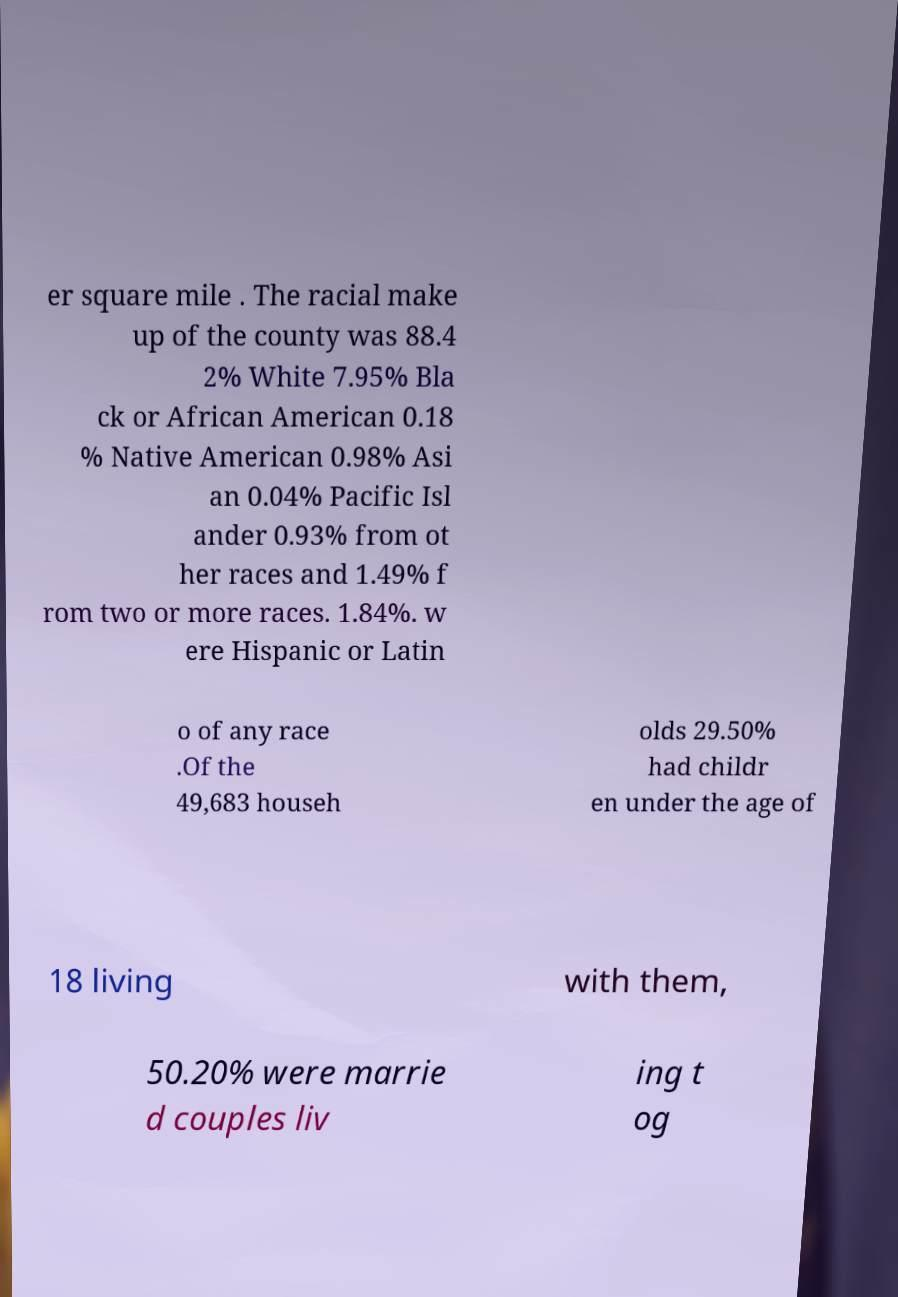Could you extract and type out the text from this image? er square mile . The racial make up of the county was 88.4 2% White 7.95% Bla ck or African American 0.18 % Native American 0.98% Asi an 0.04% Pacific Isl ander 0.93% from ot her races and 1.49% f rom two or more races. 1.84%. w ere Hispanic or Latin o of any race .Of the 49,683 househ olds 29.50% had childr en under the age of 18 living with them, 50.20% were marrie d couples liv ing t og 